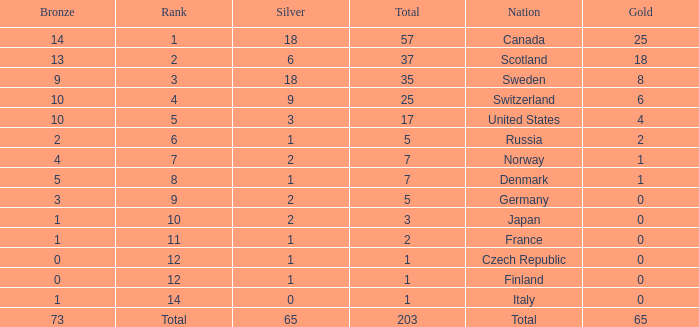What is the number of bronze medals when the total is greater than 1, more than 2 silver medals are won, and the rank is 2? 13.0. 